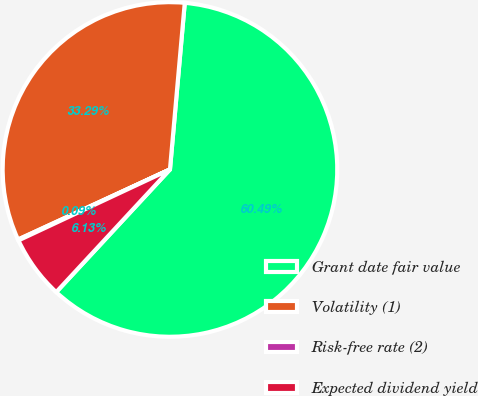Convert chart to OTSL. <chart><loc_0><loc_0><loc_500><loc_500><pie_chart><fcel>Grant date fair value<fcel>Volatility (1)<fcel>Risk-free rate (2)<fcel>Expected dividend yield<nl><fcel>60.49%<fcel>33.29%<fcel>0.09%<fcel>6.13%<nl></chart> 